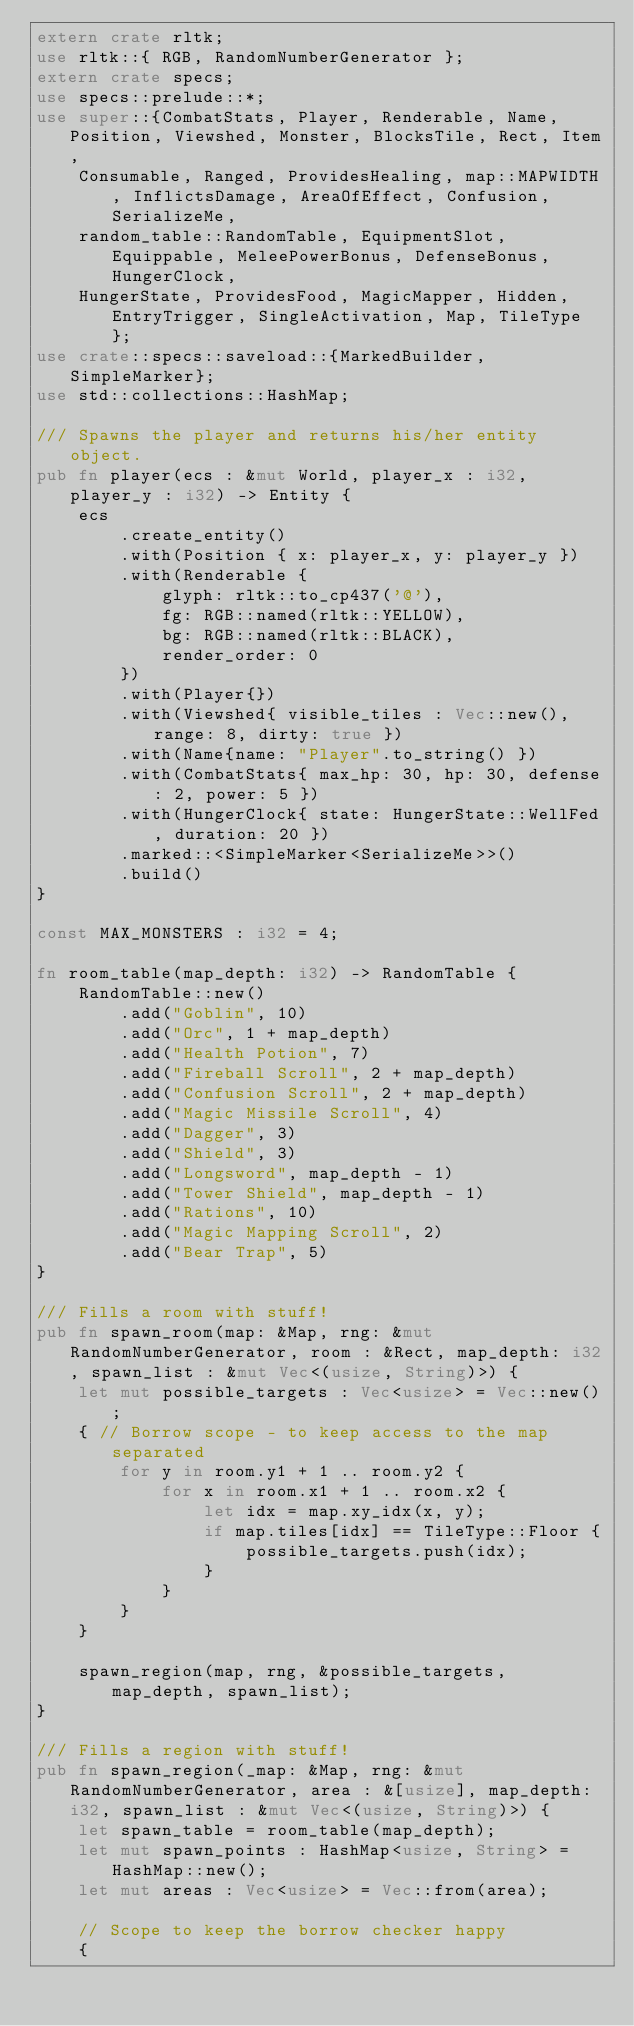<code> <loc_0><loc_0><loc_500><loc_500><_Rust_>extern crate rltk;
use rltk::{ RGB, RandomNumberGenerator };
extern crate specs;
use specs::prelude::*;
use super::{CombatStats, Player, Renderable, Name, Position, Viewshed, Monster, BlocksTile, Rect, Item,
    Consumable, Ranged, ProvidesHealing, map::MAPWIDTH, InflictsDamage, AreaOfEffect, Confusion, SerializeMe,
    random_table::RandomTable, EquipmentSlot, Equippable, MeleePowerBonus, DefenseBonus, HungerClock,
    HungerState, ProvidesFood, MagicMapper, Hidden, EntryTrigger, SingleActivation, Map, TileType };
use crate::specs::saveload::{MarkedBuilder, SimpleMarker};
use std::collections::HashMap;

/// Spawns the player and returns his/her entity object.
pub fn player(ecs : &mut World, player_x : i32, player_y : i32) -> Entity {
    ecs
        .create_entity()
        .with(Position { x: player_x, y: player_y })
        .with(Renderable {
            glyph: rltk::to_cp437('@'),
            fg: RGB::named(rltk::YELLOW),
            bg: RGB::named(rltk::BLACK),
            render_order: 0
        })
        .with(Player{})
        .with(Viewshed{ visible_tiles : Vec::new(), range: 8, dirty: true })
        .with(Name{name: "Player".to_string() })
        .with(CombatStats{ max_hp: 30, hp: 30, defense: 2, power: 5 })
        .with(HungerClock{ state: HungerState::WellFed, duration: 20 })
        .marked::<SimpleMarker<SerializeMe>>()
        .build()
}

const MAX_MONSTERS : i32 = 4;

fn room_table(map_depth: i32) -> RandomTable {
    RandomTable::new()
        .add("Goblin", 10)
        .add("Orc", 1 + map_depth)
        .add("Health Potion", 7)
        .add("Fireball Scroll", 2 + map_depth)
        .add("Confusion Scroll", 2 + map_depth)
        .add("Magic Missile Scroll", 4)
        .add("Dagger", 3)
        .add("Shield", 3)
        .add("Longsword", map_depth - 1)
        .add("Tower Shield", map_depth - 1)
        .add("Rations", 10)
        .add("Magic Mapping Scroll", 2)
        .add("Bear Trap", 5)
}

/// Fills a room with stuff!
pub fn spawn_room(map: &Map, rng: &mut RandomNumberGenerator, room : &Rect, map_depth: i32, spawn_list : &mut Vec<(usize, String)>) {
    let mut possible_targets : Vec<usize> = Vec::new();
    { // Borrow scope - to keep access to the map separated
        for y in room.y1 + 1 .. room.y2 {
            for x in room.x1 + 1 .. room.x2 {
                let idx = map.xy_idx(x, y);
                if map.tiles[idx] == TileType::Floor {
                    possible_targets.push(idx);
                }
            }
        }
    }

    spawn_region(map, rng, &possible_targets, map_depth, spawn_list);
}

/// Fills a region with stuff!
pub fn spawn_region(_map: &Map, rng: &mut RandomNumberGenerator, area : &[usize], map_depth: i32, spawn_list : &mut Vec<(usize, String)>) {
    let spawn_table = room_table(map_depth);
    let mut spawn_points : HashMap<usize, String> = HashMap::new();
    let mut areas : Vec<usize> = Vec::from(area);

    // Scope to keep the borrow checker happy
    {</code> 